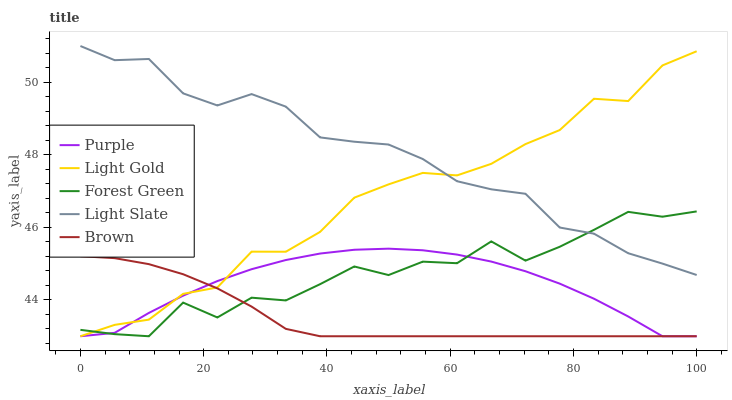Does Brown have the minimum area under the curve?
Answer yes or no. Yes. Does Light Slate have the maximum area under the curve?
Answer yes or no. Yes. Does Forest Green have the minimum area under the curve?
Answer yes or no. No. Does Forest Green have the maximum area under the curve?
Answer yes or no. No. Is Brown the smoothest?
Answer yes or no. Yes. Is Forest Green the roughest?
Answer yes or no. Yes. Is Light Slate the smoothest?
Answer yes or no. No. Is Light Slate the roughest?
Answer yes or no. No. Does Purple have the lowest value?
Answer yes or no. Yes. Does Light Slate have the lowest value?
Answer yes or no. No. Does Light Slate have the highest value?
Answer yes or no. Yes. Does Forest Green have the highest value?
Answer yes or no. No. Is Purple less than Light Slate?
Answer yes or no. Yes. Is Light Slate greater than Brown?
Answer yes or no. Yes. Does Brown intersect Forest Green?
Answer yes or no. Yes. Is Brown less than Forest Green?
Answer yes or no. No. Is Brown greater than Forest Green?
Answer yes or no. No. Does Purple intersect Light Slate?
Answer yes or no. No. 